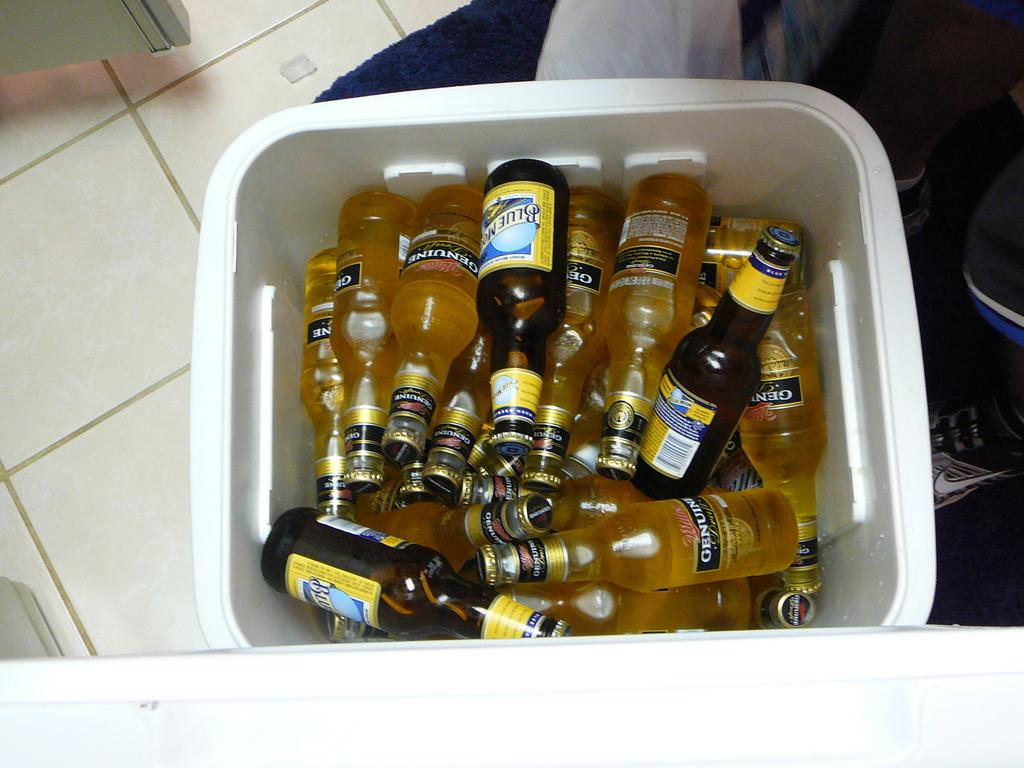What type of flooring is visible in the image? There are white color tiles in the image. What objects can be seen on the floor in the image? There are bottles visible on the floor in the image. What type of peace agreement is being discussed by the partners in the image? There are no partners or peace agreement present in the image; it only features white color tiles and bottles. 